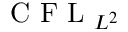Convert formula to latex. <formula><loc_0><loc_0><loc_500><loc_500>C F L _ { L ^ { 2 } }</formula> 